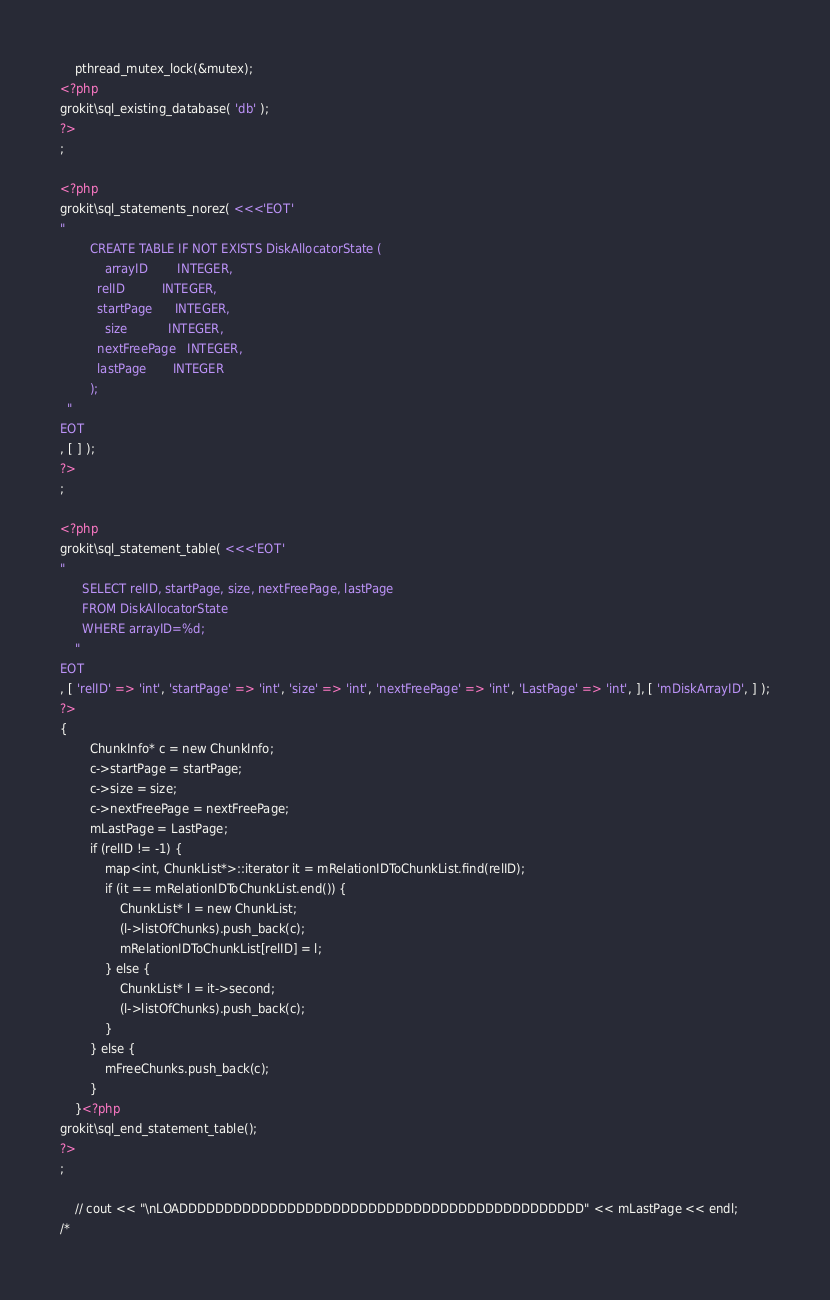Convert code to text. <code><loc_0><loc_0><loc_500><loc_500><_PHP_>    pthread_mutex_lock(&mutex);
<?php
grokit\sql_existing_database( 'db' );
?>
;

<?php
grokit\sql_statements_norez( <<<'EOT'
"
        CREATE TABLE IF NOT EXISTS DiskAllocatorState (
            arrayID        INTEGER,
          relID          INTEGER,
          startPage      INTEGER,
            size           INTEGER,
          nextFreePage   INTEGER,
          lastPage       INTEGER
        );
  "
EOT
, [ ] );
?>
;

<?php
grokit\sql_statement_table( <<<'EOT'
"
      SELECT relID, startPage, size, nextFreePage, lastPage
      FROM DiskAllocatorState
      WHERE arrayID=%d;
    "
EOT
, [ 'relID' => 'int', 'startPage' => 'int', 'size' => 'int', 'nextFreePage' => 'int', 'LastPage' => 'int', ], [ 'mDiskArrayID', ] );
?>
{
        ChunkInfo* c = new ChunkInfo;
        c->startPage = startPage;
        c->size = size;
        c->nextFreePage = nextFreePage;
        mLastPage = LastPage;
        if (relID != -1) {
            map<int, ChunkList*>::iterator it = mRelationIDToChunkList.find(relID);
            if (it == mRelationIDToChunkList.end()) {
                ChunkList* l = new ChunkList;
                (l->listOfChunks).push_back(c);
                mRelationIDToChunkList[relID] = l;
            } else {
                ChunkList* l = it->second;
                (l->listOfChunks).push_back(c);
            }
        } else {
            mFreeChunks.push_back(c);
        }
    }<?php
grokit\sql_end_statement_table();
?>
;

    // cout << "\nLOADDDDDDDDDDDDDDDDDDDDDDDDDDDDDDDDDDDDDDDDDDDDD" << mLastPage << endl;
/*</code> 